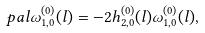Convert formula to latex. <formula><loc_0><loc_0><loc_500><loc_500>\ p a l \omega _ { 1 , 0 } ^ { ( 0 ) } ( l ) = - 2 h _ { 2 , 0 } ^ { ( 0 ) } ( l ) \omega _ { 1 , 0 } ^ { ( 0 ) } ( l ) ,</formula> 